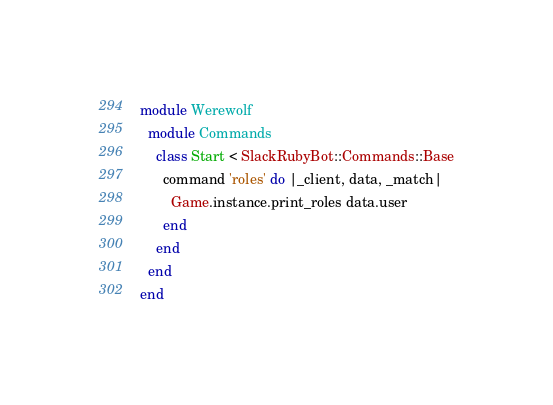<code> <loc_0><loc_0><loc_500><loc_500><_Ruby_>module Werewolf
  module Commands
    class Start < SlackRubyBot::Commands::Base
      command 'roles' do |_client, data, _match|
        Game.instance.print_roles data.user
      end
    end
  end
end
</code> 